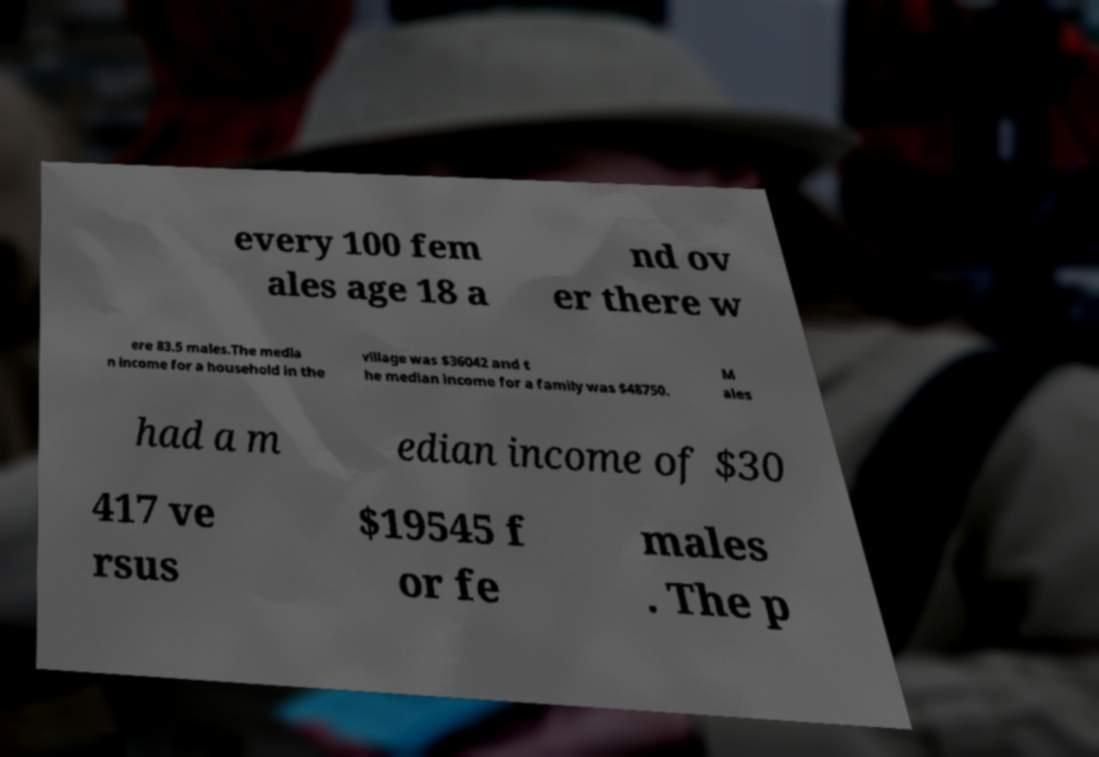There's text embedded in this image that I need extracted. Can you transcribe it verbatim? every 100 fem ales age 18 a nd ov er there w ere 83.5 males.The media n income for a household in the village was $36042 and t he median income for a family was $48750. M ales had a m edian income of $30 417 ve rsus $19545 f or fe males . The p 